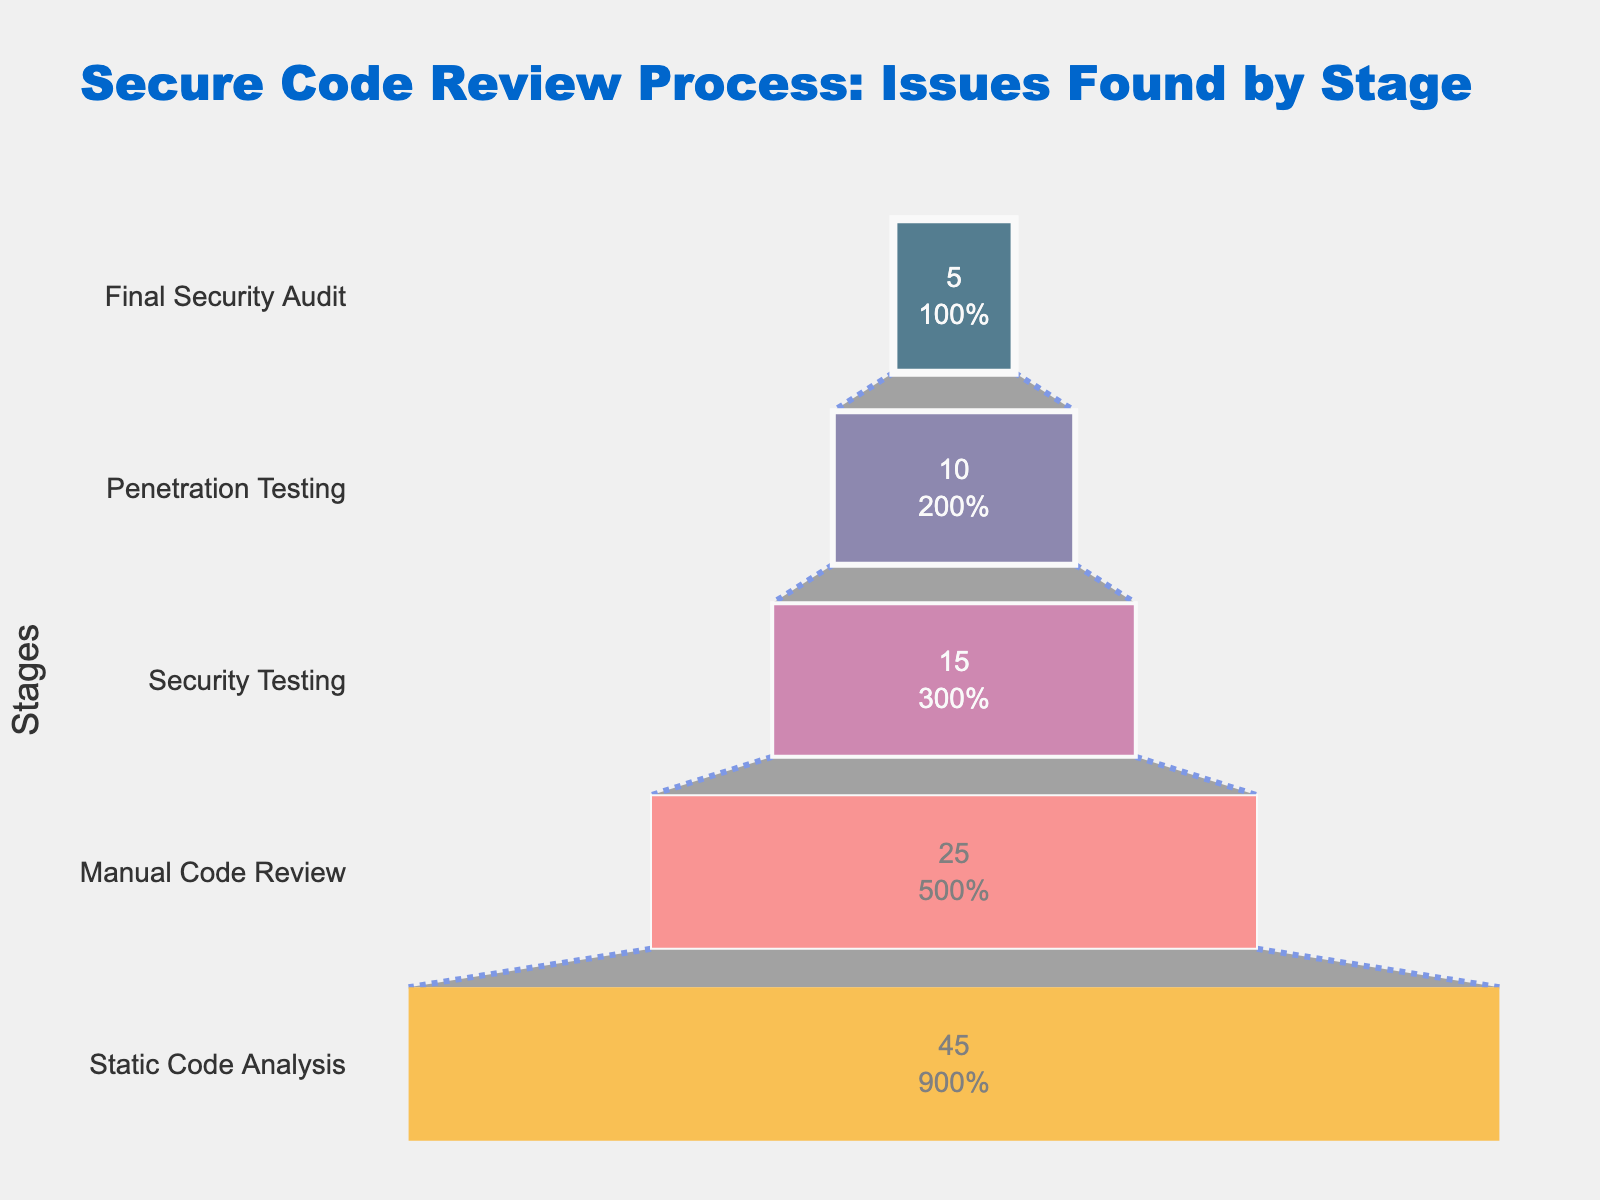What is the title of the funnel chart? The title of the chart is displayed at the top and is meant to provide a summary of the depicted data. In this chart, the title is "Secure Code Review Process: Issues Found by Stage."
Answer: Secure Code Review Process: Issues Found by Stage What percentage of issues are found during Static Code Analysis? The funnel chart shows the percentage of issues found at each stage of the secure code review process. Static Code Analysis is listed with the highest percentage, which is 45%.
Answer: 45% Which stage has the lowest percentage of issues found? Looking at the funnel chart, the stage with the lowest percentage of issues found is at the narrowest part of the funnel, which represents the Final Security Audit with 5%.
Answer: Final Security Audit What is the combined percentage of issues found during Security Testing and Penetration Testing? To find the combined percentage, add up the issues found during Security Testing (15%) and Penetration Testing (10%). The sum is 15 + 10 = 25%.
Answer: 25% How much lower is the percentage of issues found during Penetration Testing compared to Static Code Analysis? To find the difference, subtract the percentage of issues found during Penetration Testing (10%) from Static Code Analysis (45%). The difference is 45 - 10 = 35%.
Answer: 35% What is the median percentage of issues found across all the stages? To find the median, first list the percentages: 45, 25, 15, 10, 5. The median is the middle value in an ordered list, which is 15%.
Answer: 15% Compare the percentages of issues found in Manual Code Review and Final Security Audit. Which one is higher, and by how much? Manual Code Review has 25% while Final Security Audit has 5%. The difference is 25 - 5 = 20%. Therefore, Manual Code Review is higher by 20%.
Answer: Manual Code Review is higher by 20% What percentage of issues are found during the intermediate stages (i.e., Manual Code Review and Security Testing)? Add the percentages for Manual Code Review (25%) and Security Testing (15%). The sum is 25 + 15 = 40%.
Answer: 40% Does any stage find more than half of the total issues? The stage with the highest percentage is Static Code Analysis with 45%. Since 45% is less than 50%, no single stage finds more than half of the total issues.
Answer: No What percentage of issues are found in stages after the Manual Code Review stage? Add the percentages for Security Testing (15%), Penetration Testing (10%), and Final Security Audit (5%). The sum is 15 + 10 + 5 = 30%.
Answer: 30% 